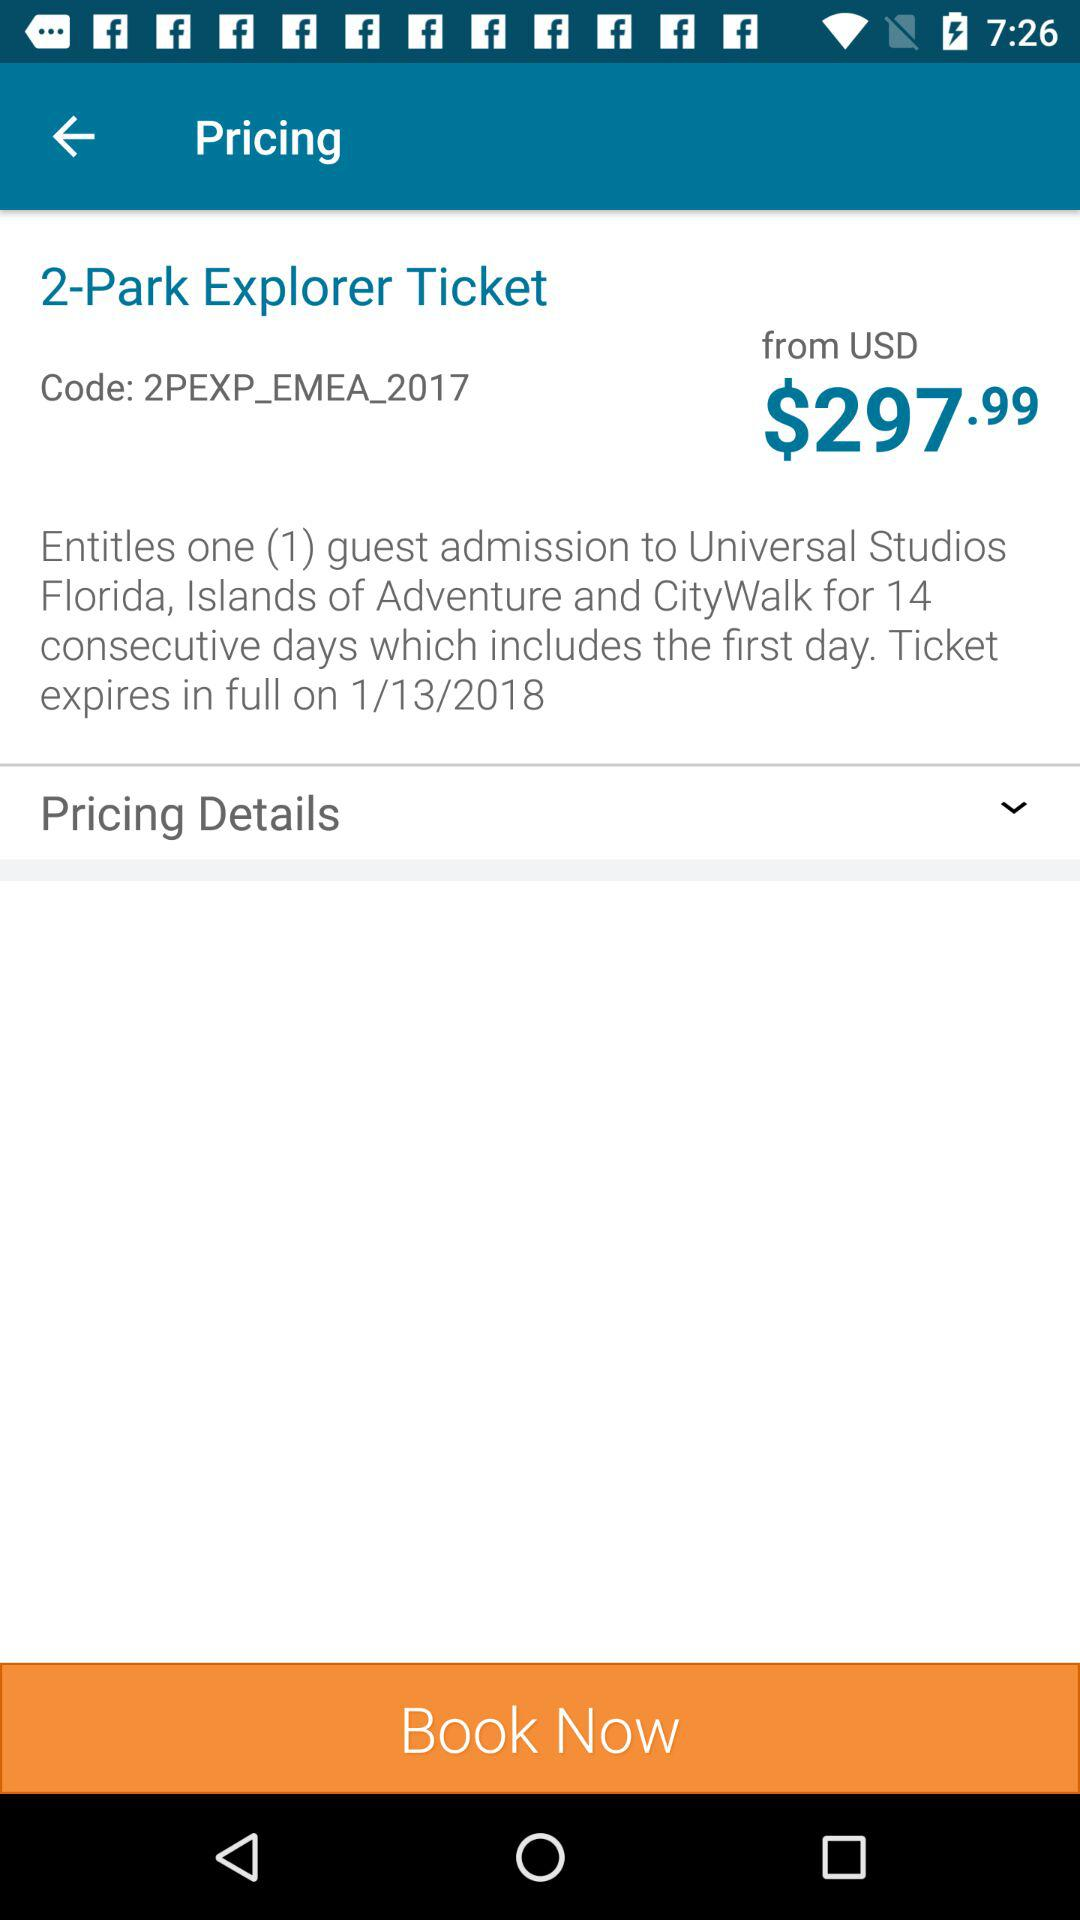What is the price of the ticket? The price of the ticket starts from USD $297.99. 